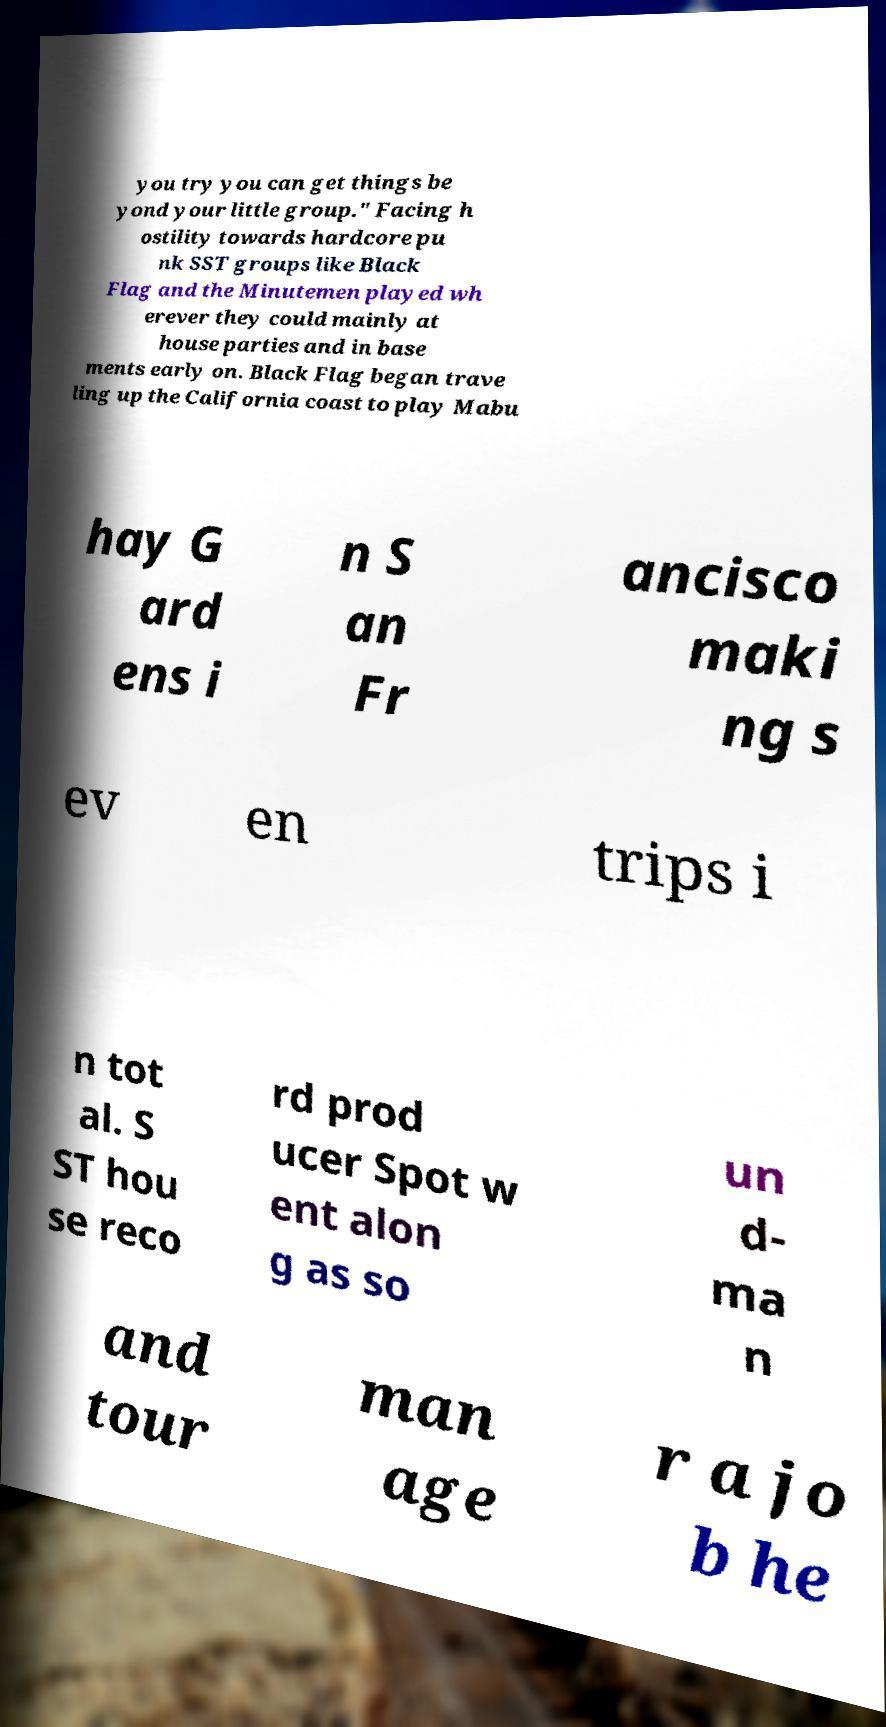Can you accurately transcribe the text from the provided image for me? you try you can get things be yond your little group." Facing h ostility towards hardcore pu nk SST groups like Black Flag and the Minutemen played wh erever they could mainly at house parties and in base ments early on. Black Flag began trave ling up the California coast to play Mabu hay G ard ens i n S an Fr ancisco maki ng s ev en trips i n tot al. S ST hou se reco rd prod ucer Spot w ent alon g as so un d- ma n and tour man age r a jo b he 